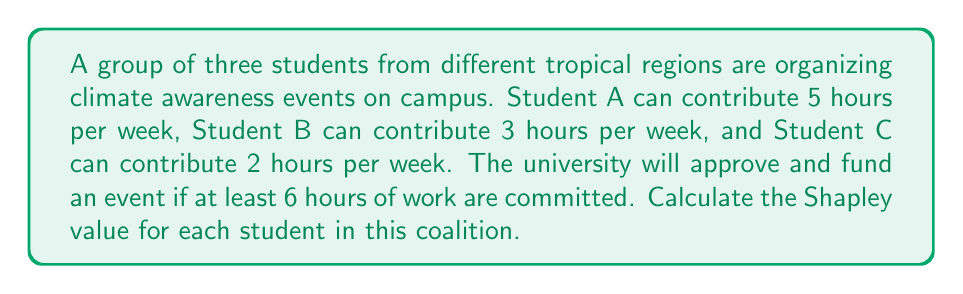Can you answer this question? To calculate the Shapley value, we need to consider all possible coalitions and the marginal contributions of each player (student) to these coalitions. Let's follow these steps:

1) First, list all possible coalitions:
   {}, {A}, {B}, {C}, {A,B}, {A,C}, {B,C}, {A,B,C}

2) Determine the value of each coalition:
   v({}) = 0 (no event approved)
   v({A}) = 0 (5 hours < 6 hours required)
   v({B}) = 0 (3 hours < 6 hours required)
   v({C}) = 0 (2 hours < 6 hours required)
   v({A,B}) = 1 (5 + 3 = 8 hours > 6 hours required)
   v({A,C}) = 1 (5 + 2 = 7 hours > 6 hours required)
   v({B,C}) = 0 (3 + 2 = 5 hours < 6 hours required)
   v({A,B,C}) = 1 (5 + 3 + 2 = 10 hours > 6 hours required)

3) Calculate marginal contributions for each player in each ordering:

   ABC: A contributes 0, B contributes 1, C contributes 0
   ACB: A contributes 0, C contributes 1, B contributes 0
   BAC: B contributes 0, A contributes 1, C contributes 0
   BCA: B contributes 0, C contributes 0, A contributes 1
   CAB: C contributes 0, A contributes 1, B contributes 0
   CBA: C contributes 0, B contributes 0, A contributes 1

4) Calculate the Shapley value for each player:

   For Student A:
   $$\phi_A = \frac{1}{6}(0 + 0 + 1 + 1 + 1 + 1) = \frac{2}{3}$$

   For Student B:
   $$\phi_B = \frac{1}{6}(1 + 0 + 0 + 0 + 0 + 0) = \frac{1}{6}$$

   For Student C:
   $$\phi_C = \frac{1}{6}(0 + 1 + 0 + 0 + 0 + 0) = \frac{1}{6}$$

The Shapley value represents the average marginal contribution of each player to the coalition, considering all possible orderings of players joining the coalition.
Answer: The Shapley values for the students are:
Student A: $\frac{2}{3}$
Student B: $\frac{1}{6}$
Student C: $\frac{1}{6}$ 